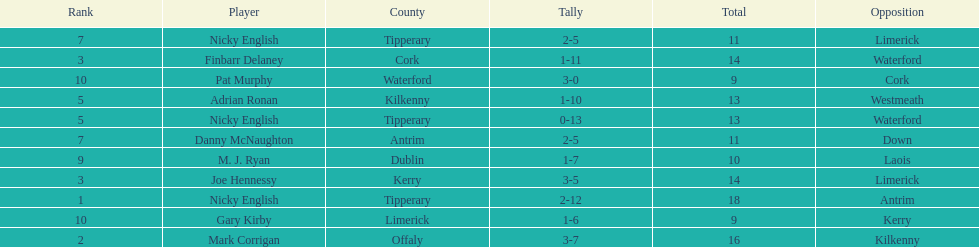What is the first name on the list? Nicky English. 